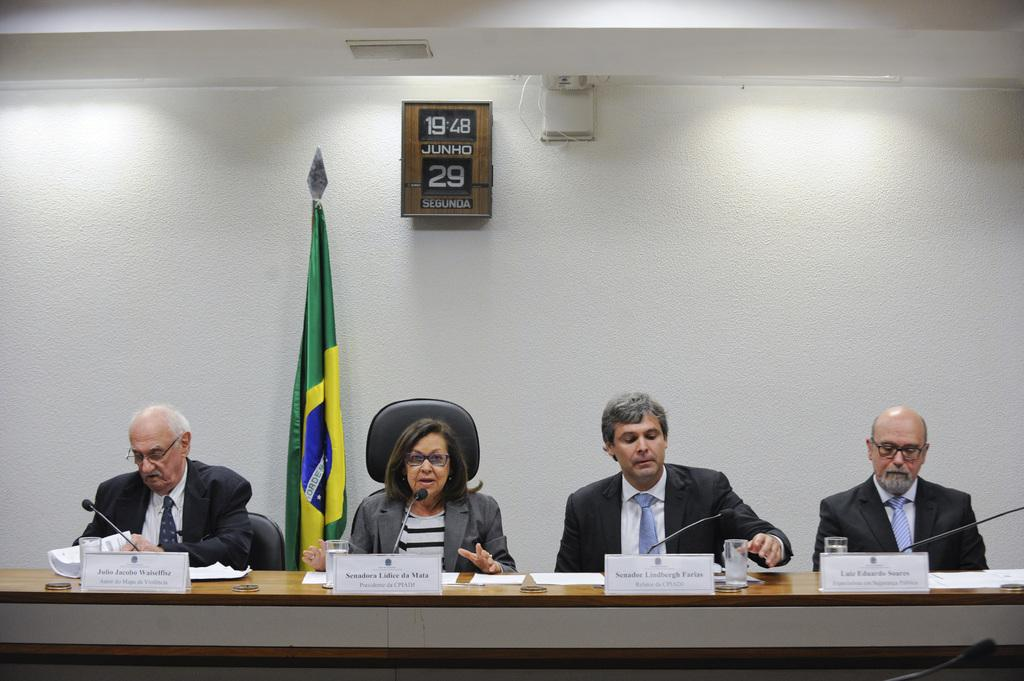How many people are in the image? There are four persons in the image. What is located behind the persons? There is a flag, a wall, and chairs visible behind the persons. Can you describe the object on the wall? There is an object on the wall, but its specific nature is not mentioned in the facts. What is visible at the top of the image? The roof is visible at the top of the image. What type of condition is the nail in, and how is it being used in the image? There is no mention of a nail in the image, so we cannot answer this question. 